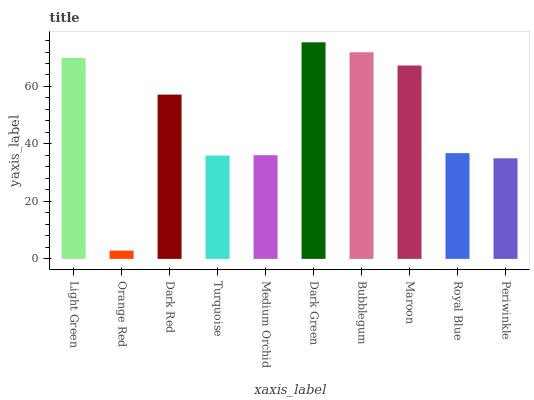Is Orange Red the minimum?
Answer yes or no. Yes. Is Dark Green the maximum?
Answer yes or no. Yes. Is Dark Red the minimum?
Answer yes or no. No. Is Dark Red the maximum?
Answer yes or no. No. Is Dark Red greater than Orange Red?
Answer yes or no. Yes. Is Orange Red less than Dark Red?
Answer yes or no. Yes. Is Orange Red greater than Dark Red?
Answer yes or no. No. Is Dark Red less than Orange Red?
Answer yes or no. No. Is Dark Red the high median?
Answer yes or no. Yes. Is Royal Blue the low median?
Answer yes or no. Yes. Is Orange Red the high median?
Answer yes or no. No. Is Bubblegum the low median?
Answer yes or no. No. 